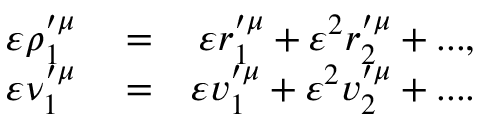Convert formula to latex. <formula><loc_0><loc_0><loc_500><loc_500>\begin{array} { r l r } { \varepsilon \rho _ { 1 } ^ { \prime \mu } } & = } & { \varepsilon r _ { 1 } ^ { \prime \mu } + \varepsilon ^ { 2 } r _ { 2 } ^ { \prime \mu } + \dots , } \\ { \varepsilon \nu _ { 1 } ^ { \prime \mu } } & = } & { \varepsilon v _ { 1 } ^ { \prime \mu } + \varepsilon ^ { 2 } v _ { 2 } ^ { \prime \mu } + \cdots } \end{array}</formula> 